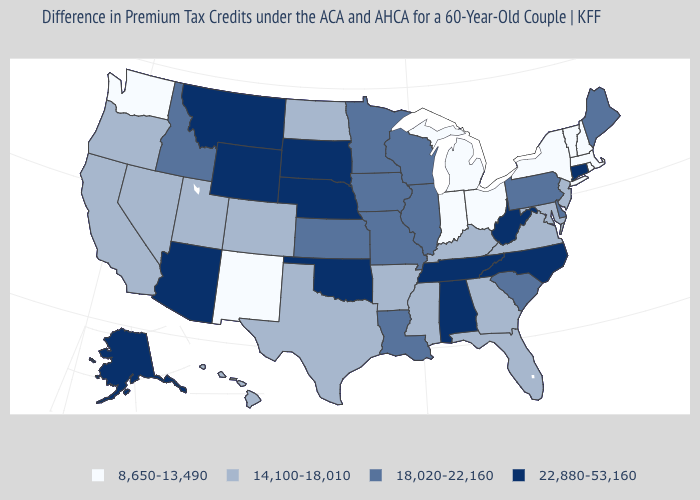Name the states that have a value in the range 8,650-13,490?
Be succinct. Indiana, Massachusetts, Michigan, New Hampshire, New Mexico, New York, Ohio, Rhode Island, Vermont, Washington. Does Georgia have a higher value than Michigan?
Give a very brief answer. Yes. Name the states that have a value in the range 18,020-22,160?
Quick response, please. Delaware, Idaho, Illinois, Iowa, Kansas, Louisiana, Maine, Minnesota, Missouri, Pennsylvania, South Carolina, Wisconsin. What is the value of Virginia?
Answer briefly. 14,100-18,010. Does Wisconsin have a lower value than Texas?
Answer briefly. No. Name the states that have a value in the range 14,100-18,010?
Answer briefly. Arkansas, California, Colorado, Florida, Georgia, Hawaii, Kentucky, Maryland, Mississippi, Nevada, New Jersey, North Dakota, Oregon, Texas, Utah, Virginia. What is the lowest value in states that border Washington?
Short answer required. 14,100-18,010. Does Kentucky have a higher value than Arizona?
Short answer required. No. What is the value of Oregon?
Answer briefly. 14,100-18,010. Which states have the lowest value in the MidWest?
Answer briefly. Indiana, Michigan, Ohio. What is the lowest value in the MidWest?
Quick response, please. 8,650-13,490. How many symbols are there in the legend?
Be succinct. 4. Which states have the lowest value in the USA?
Quick response, please. Indiana, Massachusetts, Michigan, New Hampshire, New Mexico, New York, Ohio, Rhode Island, Vermont, Washington. Name the states that have a value in the range 22,880-53,160?
Quick response, please. Alabama, Alaska, Arizona, Connecticut, Montana, Nebraska, North Carolina, Oklahoma, South Dakota, Tennessee, West Virginia, Wyoming. Name the states that have a value in the range 8,650-13,490?
Concise answer only. Indiana, Massachusetts, Michigan, New Hampshire, New Mexico, New York, Ohio, Rhode Island, Vermont, Washington. 